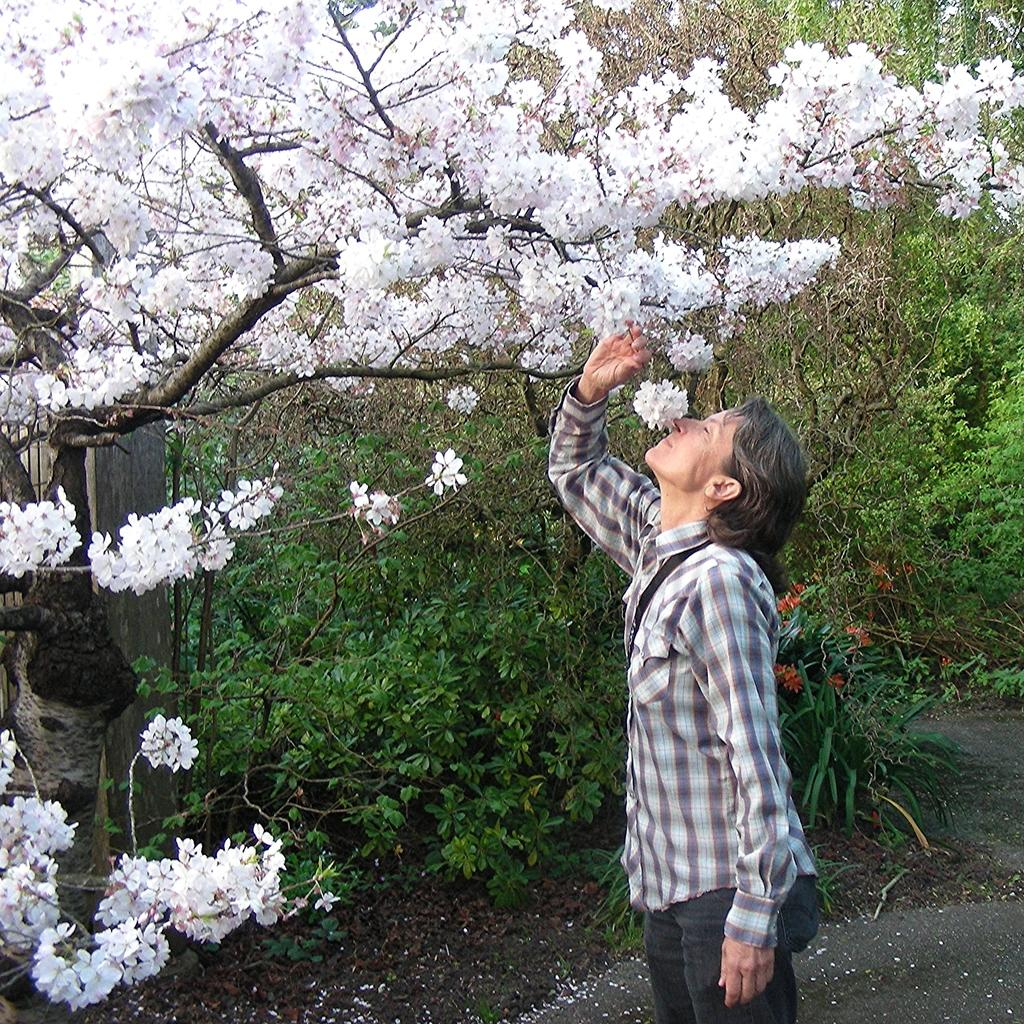What is the main subject of the image? There is a person in the image. What is the person holding in the image? The person is holding a flower from a tree. What color are the flowers on the tree? The tree has white flowers. What other vegetation can be seen in the image? There are other trees and plants in the image. What type of dirt can be seen on the girl's shoes in the image? There is no girl present in the image, and therefore no shoes or dirt to observe. 